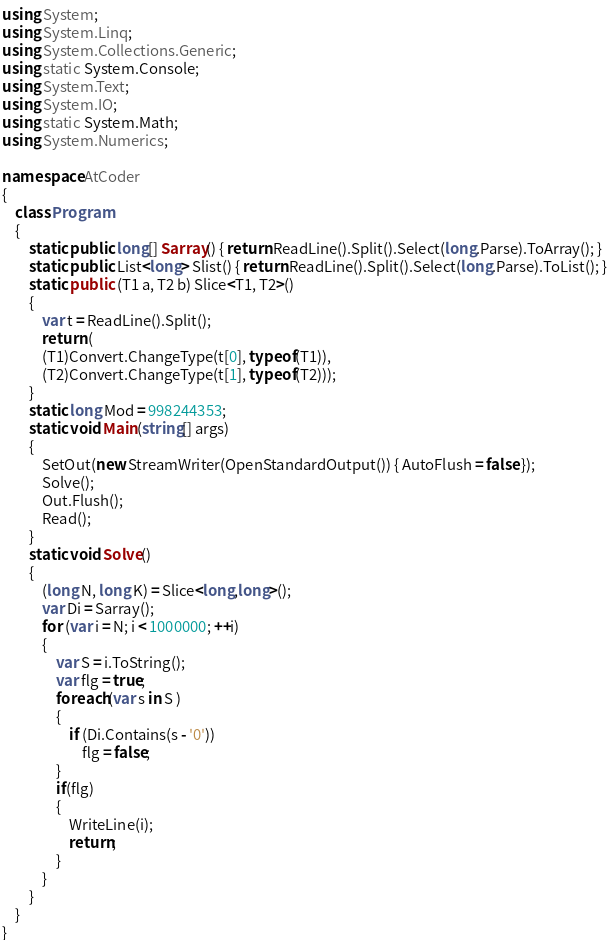<code> <loc_0><loc_0><loc_500><loc_500><_C#_>using System;
using System.Linq;
using System.Collections.Generic;
using static System.Console;
using System.Text;
using System.IO;
using static System.Math;
using System.Numerics;

namespace AtCoder
{
    class Program
    {
        static public long[] Sarray() { return ReadLine().Split().Select(long.Parse).ToArray(); }
        static public List<long> Slist() { return ReadLine().Split().Select(long.Parse).ToList(); }
        static public (T1 a, T2 b) Slice<T1, T2>()
        {
            var t = ReadLine().Split();
            return (
            (T1)Convert.ChangeType(t[0], typeof(T1)),
            (T2)Convert.ChangeType(t[1], typeof(T2)));
        }
        static long Mod = 998244353;
        static void Main(string[] args)
        {
            SetOut(new StreamWriter(OpenStandardOutput()) { AutoFlush = false });
            Solve();
            Out.Flush();
            Read();
        }
        static void Solve()
        {
            (long N, long K) = Slice<long,long>();
            var Di = Sarray();
            for (var i = N; i < 1000000; ++i)
            {
                var S = i.ToString();
                var flg = true;
                foreach(var s in S )
                {
                    if (Di.Contains(s - '0'))
                        flg = false;
                }
                if(flg)
                {
                    WriteLine(i);
                    return;
                }
            }
        }
    }
}</code> 